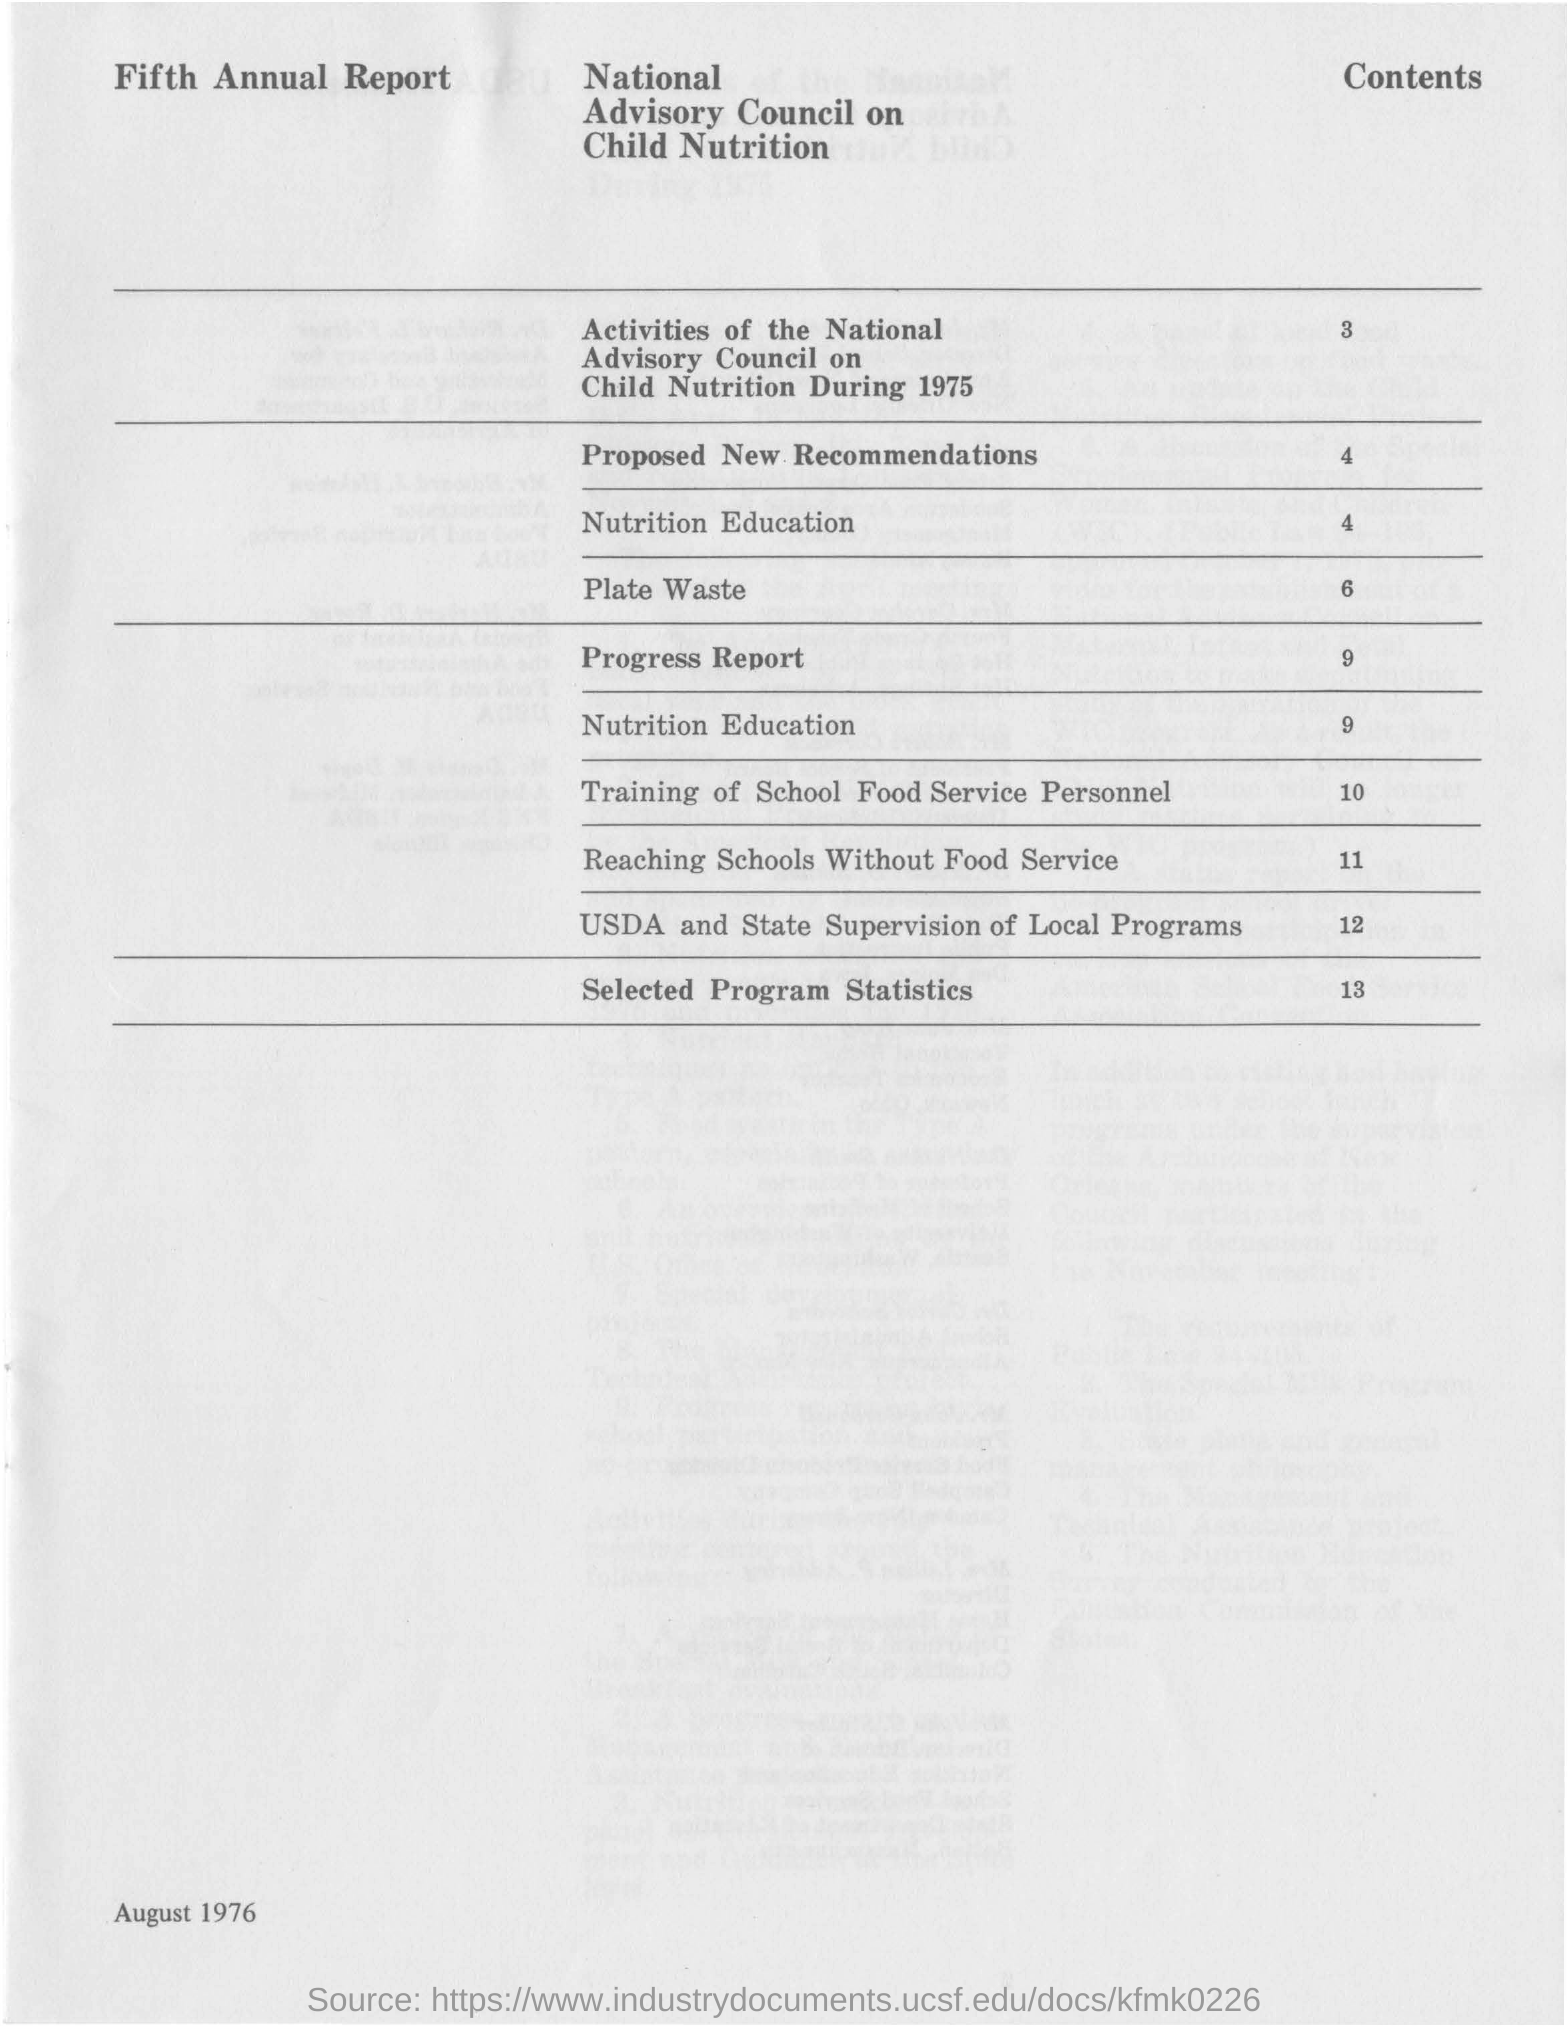What is the date mentioned in this document?
Make the answer very short. August 1976. What is the Page no of the Proposed New Recommendations?
Provide a short and direct response. 4. 